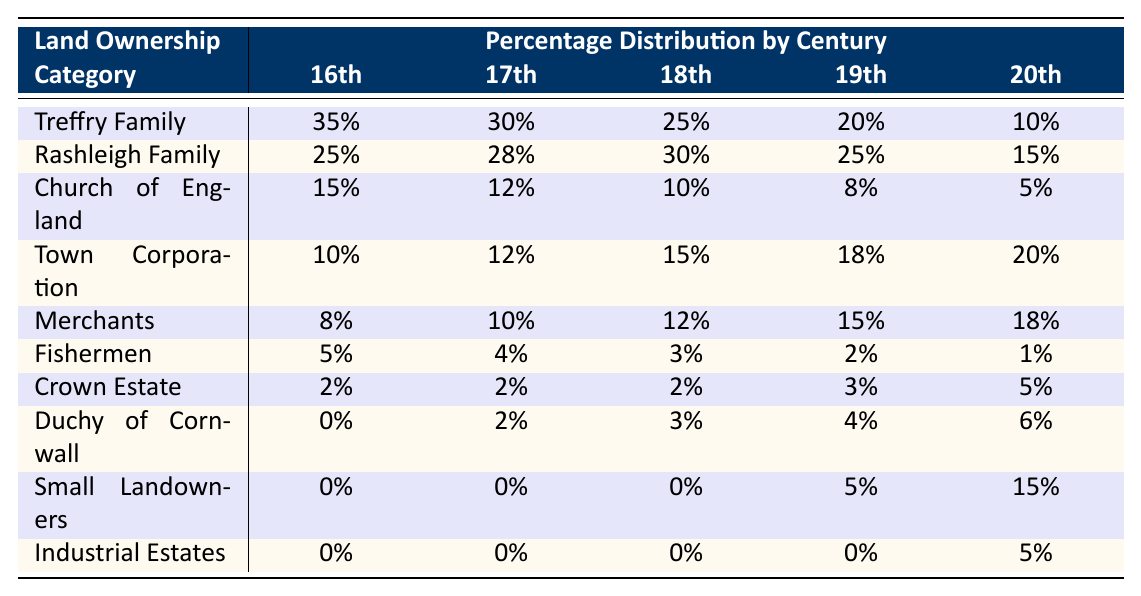What percentage of land ownership did the Treffry Family have in the 16th century? The table shows that the Treffry Family had 35% of the land ownership in the 16th century.
Answer: 35% Which land ownership category had the highest percentage in the 18th century? The table indicates that the Rashleigh Family had the highest percentage of land ownership in the 18th century, with 30%.
Answer: Rashleigh Family What is the total percentage of land ownership for the Town Corporation across all centuries? Adding the percentages for the Town Corporation: 10% + 12% + 15% + 18% + 20% equals 75%.
Answer: 75% Did the percentage of land ownership for the Fishermen ever exceed 5%? The table shows that the Fishermen’s percentage was 5% in the 16th century but decreased over the subsequent centuries, never exceeding 5%.
Answer: No In which century did the Duchy of Cornwall first show a percentage of land ownership? The Duchy of Cornwall first shows a percentage of 2% in the 17th century, as indicated in the data.
Answer: 17th century What is the difference in percentage of land ownership between the Rashleigh Family and Town Corporation in the 19th century? The Rashleigh Family had 25%, while the Town Corporation had 18% in the 19th century. The difference is 25% - 18% = 7%.
Answer: 7% How did the percentage of land ownership for Small Landowners change from the 19th to the 20th century? In the 19th century, Small Landowners had 5%, which increased to 15% in the 20th century, indicating an increase of 10%.
Answer: Increased by 10% What was the lowest percentage of land ownership recorded for the Fishermen across all centuries? The lowest percentage for the Fishermen was 1% in the 20th century, as shown in the table.
Answer: 1% Which land ownership category showed the most significant increase in percentage from the 19th to the 20th century? The Small Landowners increased from 5% in the 19th century to 15% in the 20th century, a rise of 10%. This is the most significant increase.
Answer: Small Landowners If the total land ownership is considered 100%, what percentage of land was owned by the Crown Estate across all centuries? The percentages for the Crown Estate are 2% + 2% + 2% + 3% + 5%, totaling 14% across all centuries.
Answer: 14% 